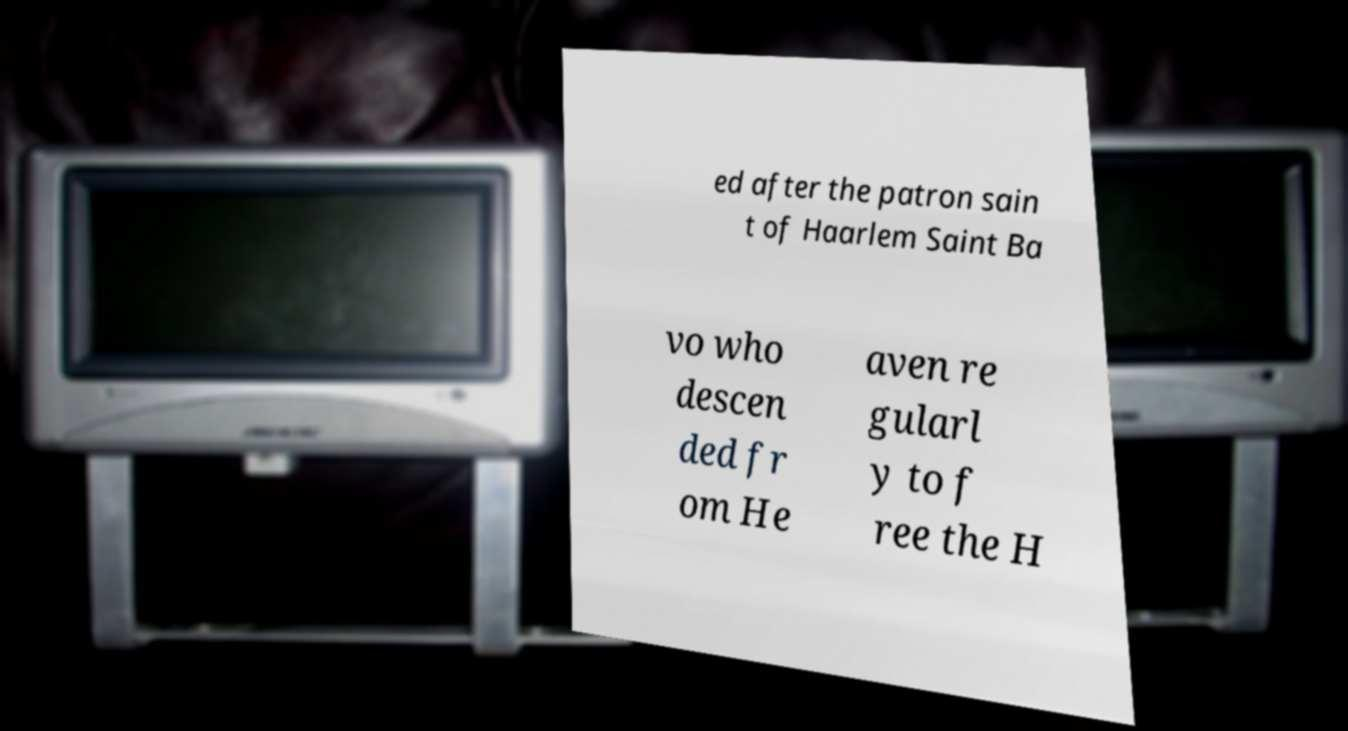Can you accurately transcribe the text from the provided image for me? ed after the patron sain t of Haarlem Saint Ba vo who descen ded fr om He aven re gularl y to f ree the H 